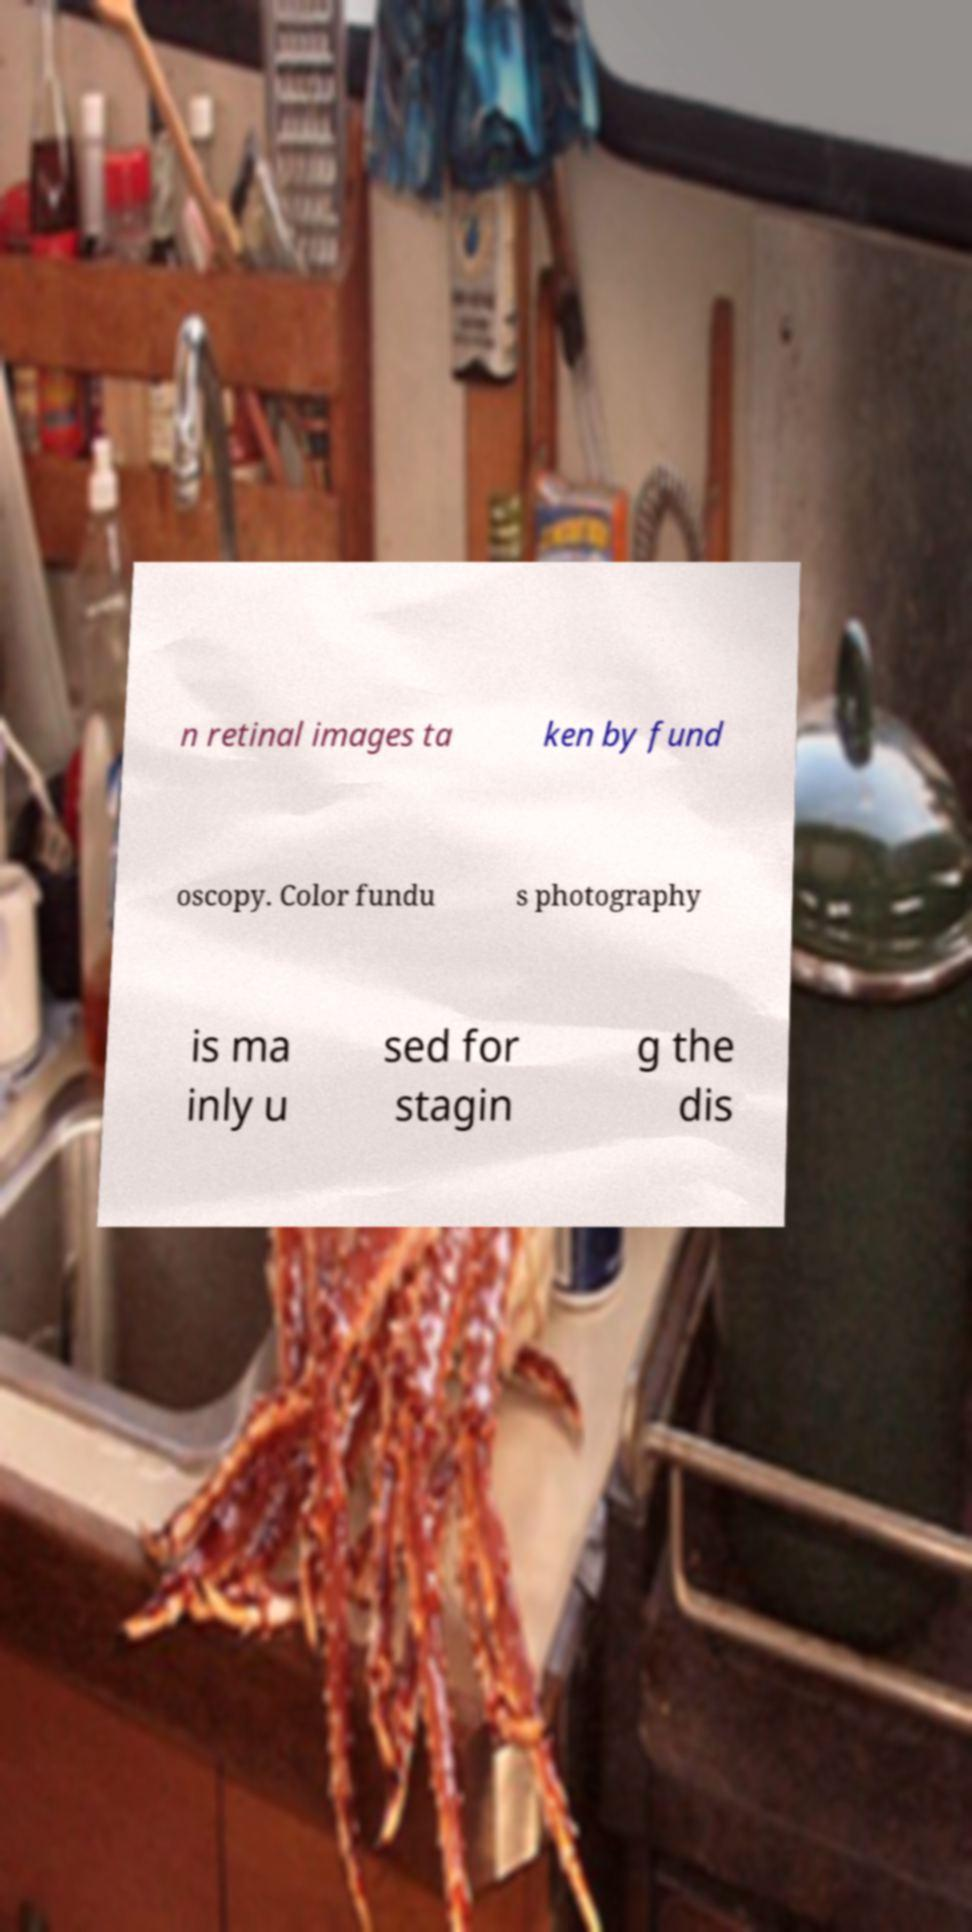Please read and relay the text visible in this image. What does it say? n retinal images ta ken by fund oscopy. Color fundu s photography is ma inly u sed for stagin g the dis 